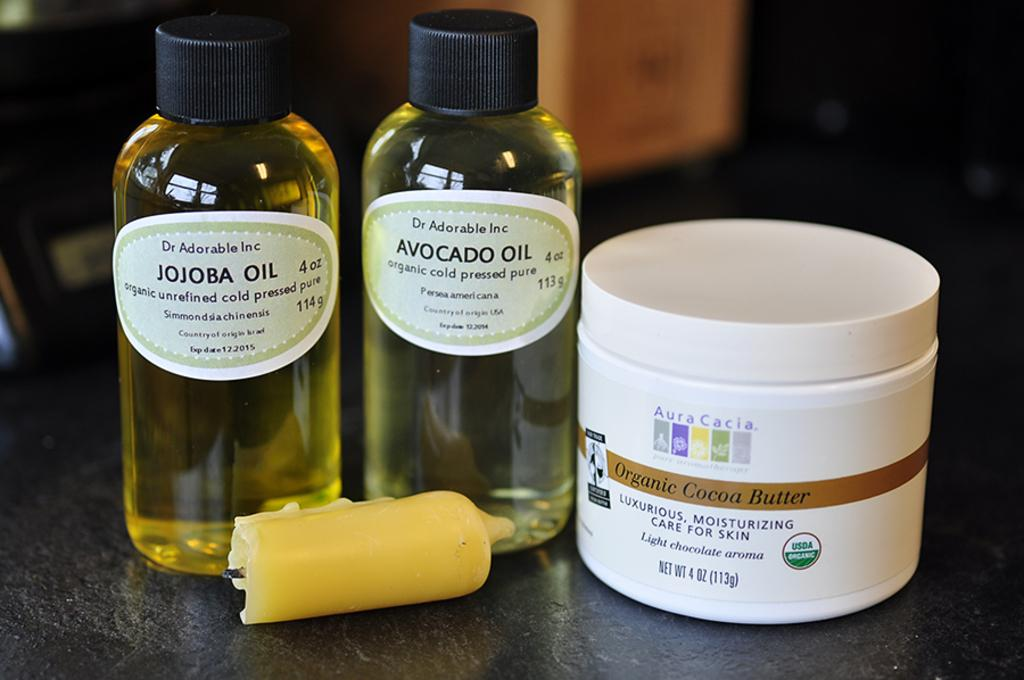What objects can be seen in the image? There are bottles, a box, and a candle in the image. What feature do the bottles and box have in common? The bottles and box have labels with visible text. What is the purpose of the candle in the image? The purpose of the candle is not explicitly stated, but it could be for lighting or decoration. How would you describe the background of the image? The background of the image is blurred. How many flowers are present in the image? There are no flowers visible in the image. What type of army is depicted in the image? There is no army or military presence in the image. 